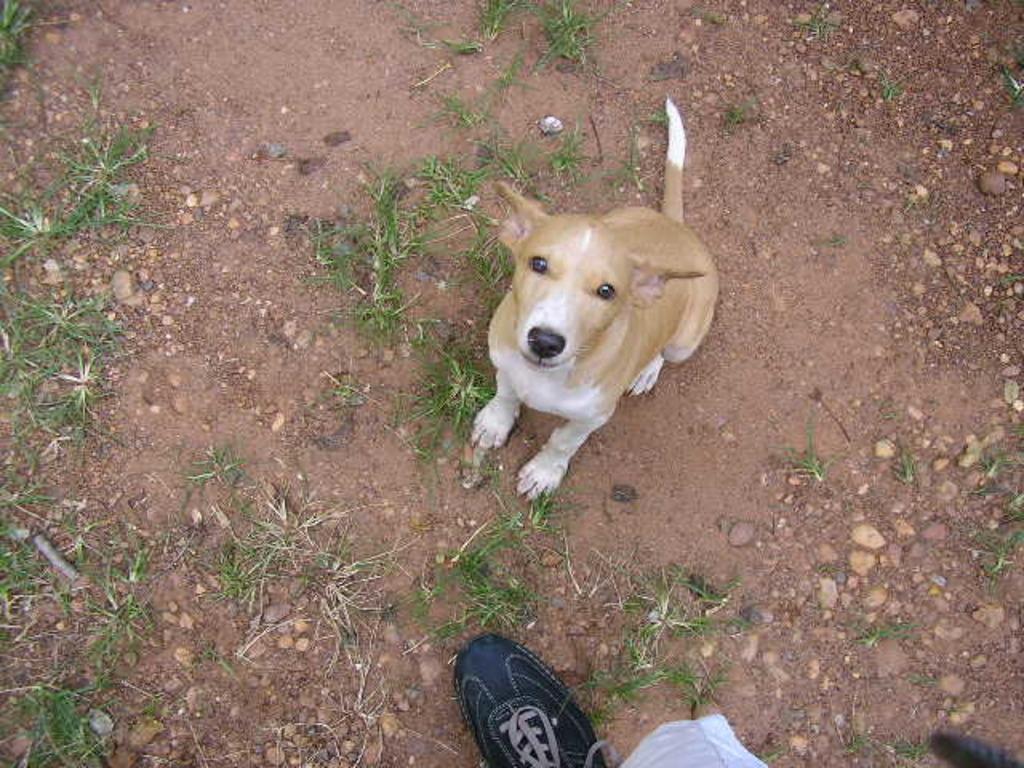Can you describe this image briefly? In this image we can see a dog. Also we can see shoe. On the ground there are stones and grass. 